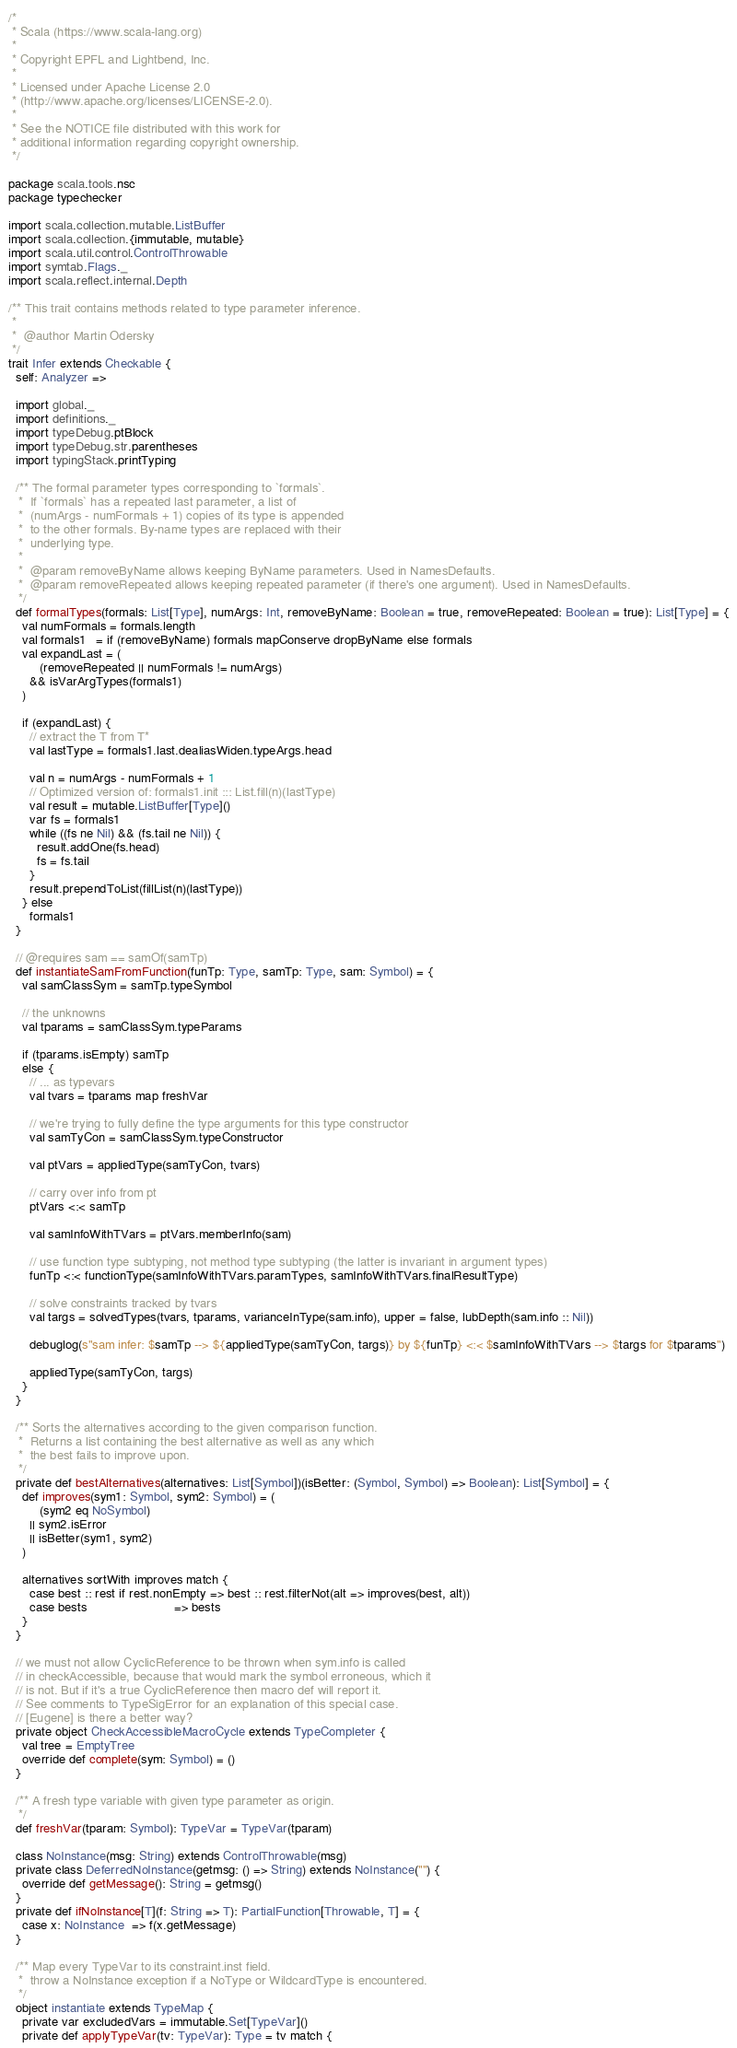Convert code to text. <code><loc_0><loc_0><loc_500><loc_500><_Scala_>/*
 * Scala (https://www.scala-lang.org)
 *
 * Copyright EPFL and Lightbend, Inc.
 *
 * Licensed under Apache License 2.0
 * (http://www.apache.org/licenses/LICENSE-2.0).
 *
 * See the NOTICE file distributed with this work for
 * additional information regarding copyright ownership.
 */

package scala.tools.nsc
package typechecker

import scala.collection.mutable.ListBuffer
import scala.collection.{immutable, mutable}
import scala.util.control.ControlThrowable
import symtab.Flags._
import scala.reflect.internal.Depth

/** This trait contains methods related to type parameter inference.
 *
 *  @author Martin Odersky
 */
trait Infer extends Checkable {
  self: Analyzer =>

  import global._
  import definitions._
  import typeDebug.ptBlock
  import typeDebug.str.parentheses
  import typingStack.printTyping

  /** The formal parameter types corresponding to `formals`.
   *  If `formals` has a repeated last parameter, a list of
   *  (numArgs - numFormals + 1) copies of its type is appended
   *  to the other formals. By-name types are replaced with their
   *  underlying type.
   *
   *  @param removeByName allows keeping ByName parameters. Used in NamesDefaults.
   *  @param removeRepeated allows keeping repeated parameter (if there's one argument). Used in NamesDefaults.
   */
  def formalTypes(formals: List[Type], numArgs: Int, removeByName: Boolean = true, removeRepeated: Boolean = true): List[Type] = {
    val numFormals = formals.length
    val formals1   = if (removeByName) formals mapConserve dropByName else formals
    val expandLast = (
         (removeRepeated || numFormals != numArgs)
      && isVarArgTypes(formals1)
    )

    if (expandLast) {
      // extract the T from T*
      val lastType = formals1.last.dealiasWiden.typeArgs.head

      val n = numArgs - numFormals + 1
      // Optimized version of: formals1.init ::: List.fill(n)(lastType)
      val result = mutable.ListBuffer[Type]()
      var fs = formals1
      while ((fs ne Nil) && (fs.tail ne Nil)) {
        result.addOne(fs.head)
        fs = fs.tail
      }
      result.prependToList(fillList(n)(lastType))
    } else
      formals1
  }

  // @requires sam == samOf(samTp)
  def instantiateSamFromFunction(funTp: Type, samTp: Type, sam: Symbol) = {
    val samClassSym = samTp.typeSymbol

    // the unknowns
    val tparams = samClassSym.typeParams

    if (tparams.isEmpty) samTp
    else {
      // ... as typevars
      val tvars = tparams map freshVar

      // we're trying to fully define the type arguments for this type constructor
      val samTyCon = samClassSym.typeConstructor

      val ptVars = appliedType(samTyCon, tvars)

      // carry over info from pt
      ptVars <:< samTp

      val samInfoWithTVars = ptVars.memberInfo(sam)

      // use function type subtyping, not method type subtyping (the latter is invariant in argument types)
      funTp <:< functionType(samInfoWithTVars.paramTypes, samInfoWithTVars.finalResultType)

      // solve constraints tracked by tvars
      val targs = solvedTypes(tvars, tparams, varianceInType(sam.info), upper = false, lubDepth(sam.info :: Nil))

      debuglog(s"sam infer: $samTp --> ${appliedType(samTyCon, targs)} by ${funTp} <:< $samInfoWithTVars --> $targs for $tparams")

      appliedType(samTyCon, targs)
    }
  }

  /** Sorts the alternatives according to the given comparison function.
   *  Returns a list containing the best alternative as well as any which
   *  the best fails to improve upon.
   */
  private def bestAlternatives(alternatives: List[Symbol])(isBetter: (Symbol, Symbol) => Boolean): List[Symbol] = {
    def improves(sym1: Symbol, sym2: Symbol) = (
         (sym2 eq NoSymbol)
      || sym2.isError
      || isBetter(sym1, sym2)
    )

    alternatives sortWith improves match {
      case best :: rest if rest.nonEmpty => best :: rest.filterNot(alt => improves(best, alt))
      case bests                         => bests
    }
  }

  // we must not allow CyclicReference to be thrown when sym.info is called
  // in checkAccessible, because that would mark the symbol erroneous, which it
  // is not. But if it's a true CyclicReference then macro def will report it.
  // See comments to TypeSigError for an explanation of this special case.
  // [Eugene] is there a better way?
  private object CheckAccessibleMacroCycle extends TypeCompleter {
    val tree = EmptyTree
    override def complete(sym: Symbol) = ()
  }

  /** A fresh type variable with given type parameter as origin.
   */
  def freshVar(tparam: Symbol): TypeVar = TypeVar(tparam)

  class NoInstance(msg: String) extends ControlThrowable(msg)
  private class DeferredNoInstance(getmsg: () => String) extends NoInstance("") {
    override def getMessage(): String = getmsg()
  }
  private def ifNoInstance[T](f: String => T): PartialFunction[Throwable, T] = {
    case x: NoInstance  => f(x.getMessage)
  }

  /** Map every TypeVar to its constraint.inst field.
   *  throw a NoInstance exception if a NoType or WildcardType is encountered.
   */
  object instantiate extends TypeMap {
    private var excludedVars = immutable.Set[TypeVar]()
    private def applyTypeVar(tv: TypeVar): Type = tv match {</code> 